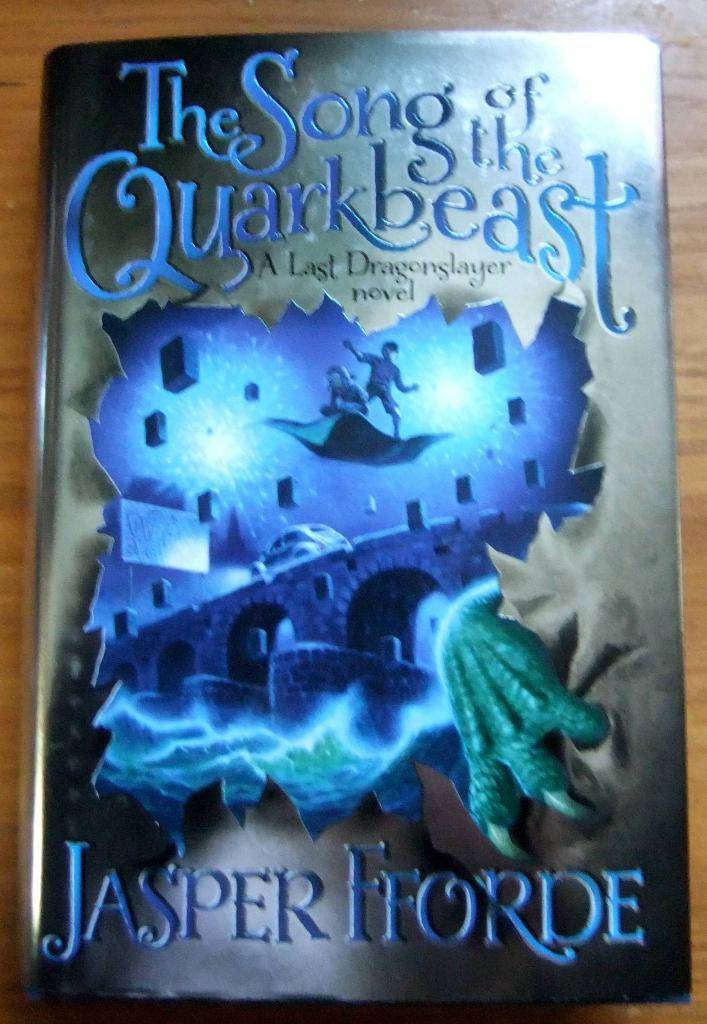<image>
Share a concise interpretation of the image provided. A book cover titled The Song of the Quarkbeast. 